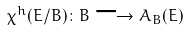<formula> <loc_0><loc_0><loc_500><loc_500>\chi ^ { h } ( E / B ) \colon B \longrightarrow A _ { B } ( E )</formula> 